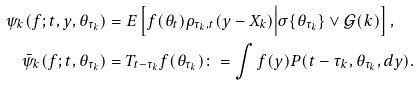<formula> <loc_0><loc_0><loc_500><loc_500>\psi _ { k } ( f ; t , y , \theta _ { \tau _ { k } } ) & = E \left [ f ( \theta _ { t } ) \rho _ { { \tau _ { k } , t } } ( y - X _ { k } ) \Big | \sigma \{ \theta _ { \tau _ { k } } \} \vee \mathcal { G } ( k ) \right ] , \\ \bar { \psi } _ { k } ( f ; t , \theta _ { \tau _ { k } } ) & = T _ { t - \tau _ { k } } f ( \theta _ { \tau _ { k } } ) \colon = \int f ( y ) P ( t - \tau _ { k } , \theta _ { \tau _ { k } } , d y ) .</formula> 